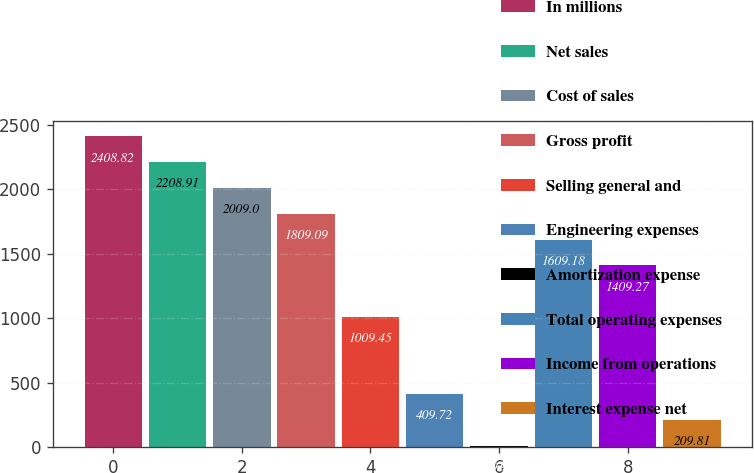<chart> <loc_0><loc_0><loc_500><loc_500><bar_chart><fcel>In millions<fcel>Net sales<fcel>Cost of sales<fcel>Gross profit<fcel>Selling general and<fcel>Engineering expenses<fcel>Amortization expense<fcel>Total operating expenses<fcel>Income from operations<fcel>Interest expense net<nl><fcel>2408.82<fcel>2208.91<fcel>2009<fcel>1809.09<fcel>1009.45<fcel>409.72<fcel>9.9<fcel>1609.18<fcel>1409.27<fcel>209.81<nl></chart> 